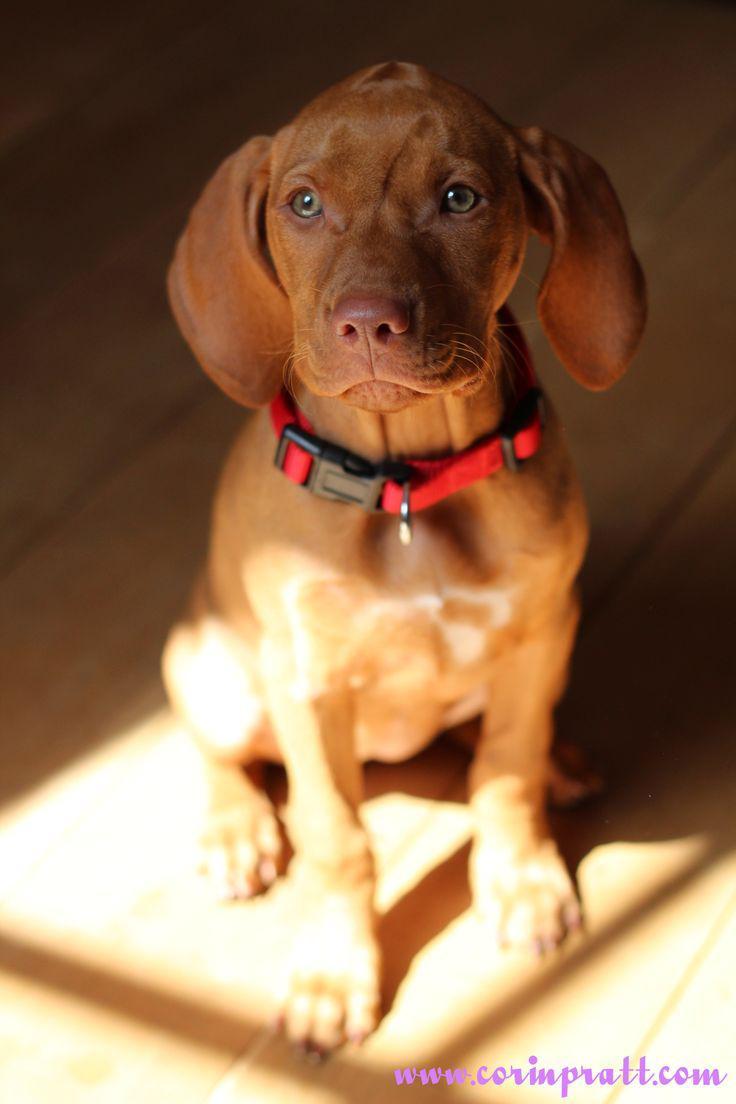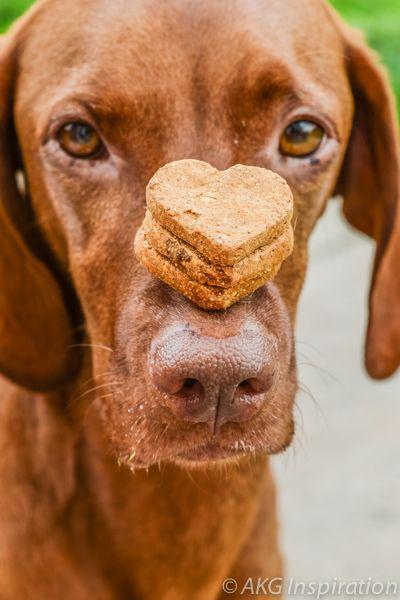The first image is the image on the left, the second image is the image on the right. Evaluate the accuracy of this statement regarding the images: "There are more than three puppies sleeping in the image.". Is it true? Answer yes or no. No. The first image is the image on the left, the second image is the image on the right. For the images displayed, is the sentence "One image shows a container holding seven red-orange puppies, and the other image shows one sleeping adult dog." factually correct? Answer yes or no. No. 